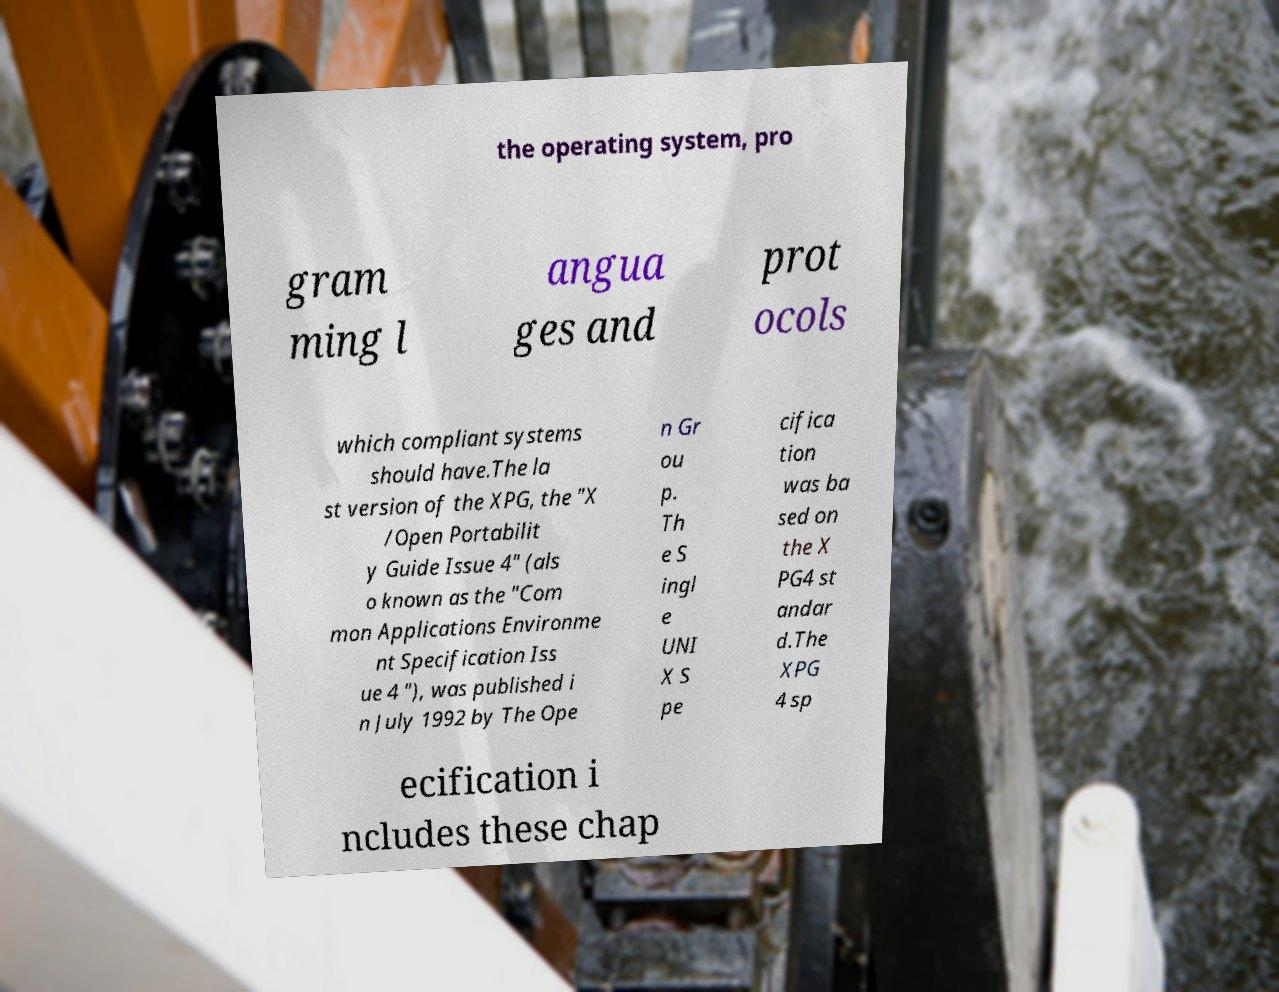Please read and relay the text visible in this image. What does it say? the operating system, pro gram ming l angua ges and prot ocols which compliant systems should have.The la st version of the XPG, the "X /Open Portabilit y Guide Issue 4" (als o known as the "Com mon Applications Environme nt Specification Iss ue 4 "), was published i n July 1992 by The Ope n Gr ou p. Th e S ingl e UNI X S pe cifica tion was ba sed on the X PG4 st andar d.The XPG 4 sp ecification i ncludes these chap 